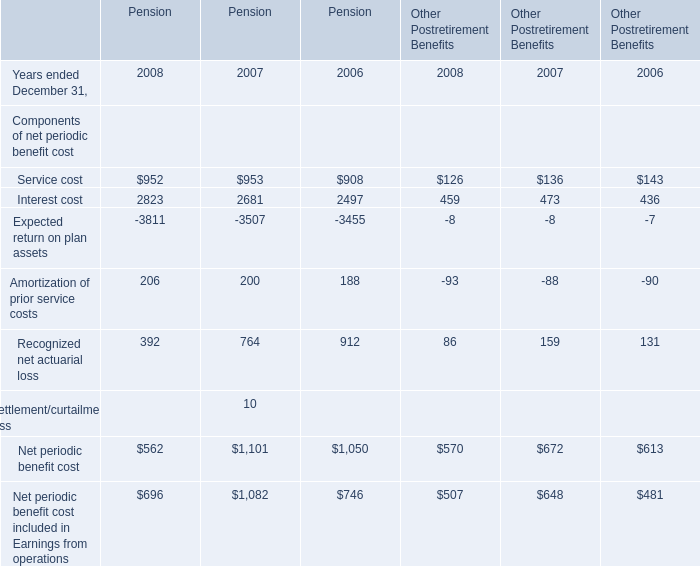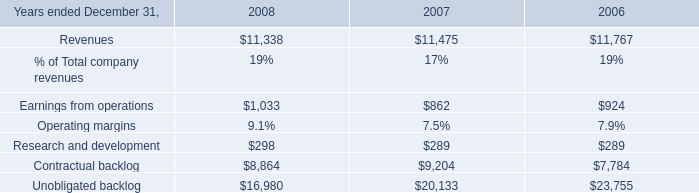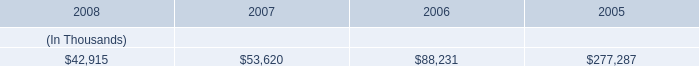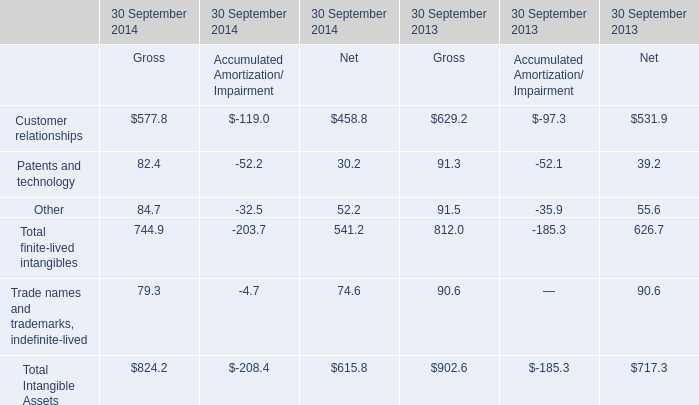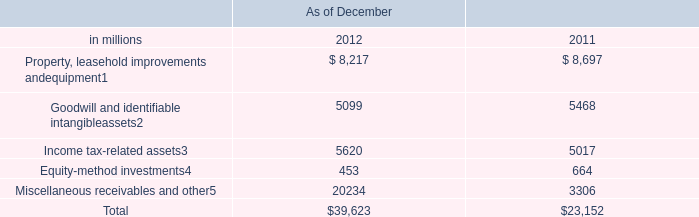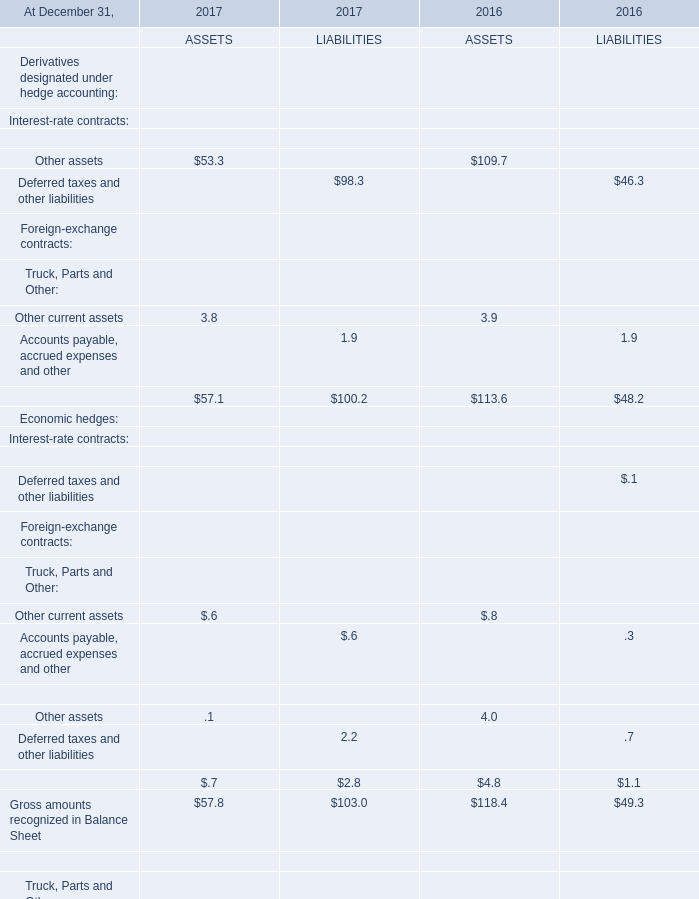What's the total amount of the Recognized net actuarial loss in the years where Amortization of prior service costs is greater than 190? 
Computations: (392 + 764)
Answer: 1156.0. 